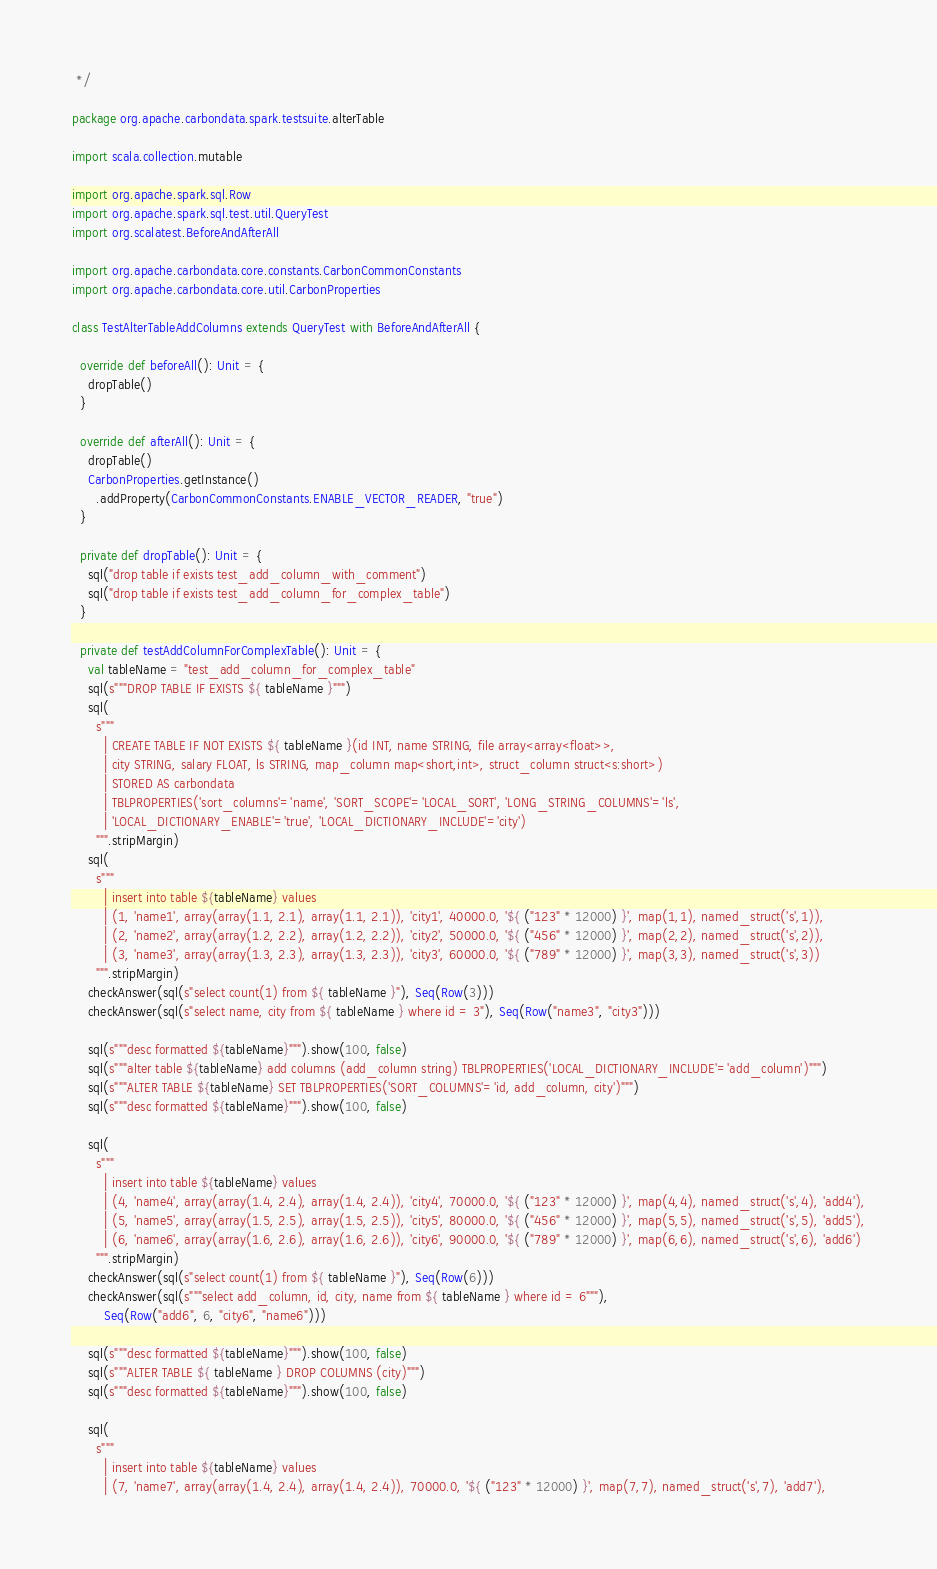<code> <loc_0><loc_0><loc_500><loc_500><_Scala_> */

package org.apache.carbondata.spark.testsuite.alterTable

import scala.collection.mutable

import org.apache.spark.sql.Row
import org.apache.spark.sql.test.util.QueryTest
import org.scalatest.BeforeAndAfterAll

import org.apache.carbondata.core.constants.CarbonCommonConstants
import org.apache.carbondata.core.util.CarbonProperties

class TestAlterTableAddColumns extends QueryTest with BeforeAndAfterAll {

  override def beforeAll(): Unit = {
    dropTable()
  }

  override def afterAll(): Unit = {
    dropTable()
    CarbonProperties.getInstance()
      .addProperty(CarbonCommonConstants.ENABLE_VECTOR_READER, "true")
  }

  private def dropTable(): Unit = {
    sql("drop table if exists test_add_column_with_comment")
    sql("drop table if exists test_add_column_for_complex_table")
  }

  private def testAddColumnForComplexTable(): Unit = {
    val tableName = "test_add_column_for_complex_table"
    sql(s"""DROP TABLE IF EXISTS ${ tableName }""")
    sql(
      s"""
        | CREATE TABLE IF NOT EXISTS ${ tableName }(id INT, name STRING, file array<array<float>>,
        | city STRING, salary FLOAT, ls STRING, map_column map<short,int>, struct_column struct<s:short>)
        | STORED AS carbondata
        | TBLPROPERTIES('sort_columns'='name', 'SORT_SCOPE'='LOCAL_SORT', 'LONG_STRING_COLUMNS'='ls',
        | 'LOCAL_DICTIONARY_ENABLE'='true', 'LOCAL_DICTIONARY_INCLUDE'='city')
      """.stripMargin)
    sql(
      s"""
        | insert into table ${tableName} values
        | (1, 'name1', array(array(1.1, 2.1), array(1.1, 2.1)), 'city1', 40000.0, '${ ("123" * 12000) }', map(1,1), named_struct('s',1)),
        | (2, 'name2', array(array(1.2, 2.2), array(1.2, 2.2)), 'city2', 50000.0, '${ ("456" * 12000) }', map(2,2), named_struct('s',2)),
        | (3, 'name3', array(array(1.3, 2.3), array(1.3, 2.3)), 'city3', 60000.0, '${ ("789" * 12000) }', map(3,3), named_struct('s',3))
      """.stripMargin)
    checkAnswer(sql(s"select count(1) from ${ tableName }"), Seq(Row(3)))
    checkAnswer(sql(s"select name, city from ${ tableName } where id = 3"), Seq(Row("name3", "city3")))

    sql(s"""desc formatted ${tableName}""").show(100, false)
    sql(s"""alter table ${tableName} add columns (add_column string) TBLPROPERTIES('LOCAL_DICTIONARY_INCLUDE'='add_column')""")
    sql(s"""ALTER TABLE ${tableName} SET TBLPROPERTIES('SORT_COLUMNS'='id, add_column, city')""")
    sql(s"""desc formatted ${tableName}""").show(100, false)

    sql(
      s"""
        | insert into table ${tableName} values
        | (4, 'name4', array(array(1.4, 2.4), array(1.4, 2.4)), 'city4', 70000.0, '${ ("123" * 12000) }', map(4,4), named_struct('s',4), 'add4'),
        | (5, 'name5', array(array(1.5, 2.5), array(1.5, 2.5)), 'city5', 80000.0, '${ ("456" * 12000) }', map(5,5), named_struct('s',5), 'add5'),
        | (6, 'name6', array(array(1.6, 2.6), array(1.6, 2.6)), 'city6', 90000.0, '${ ("789" * 12000) }', map(6,6), named_struct('s',6), 'add6')
      """.stripMargin)
    checkAnswer(sql(s"select count(1) from ${ tableName }"), Seq(Row(6)))
    checkAnswer(sql(s"""select add_column, id, city, name from ${ tableName } where id = 6"""),
        Seq(Row("add6", 6, "city6", "name6")))

    sql(s"""desc formatted ${tableName}""").show(100, false)
    sql(s"""ALTER TABLE ${ tableName } DROP COLUMNS (city)""")
    sql(s"""desc formatted ${tableName}""").show(100, false)

    sql(
      s"""
        | insert into table ${tableName} values
        | (7, 'name7', array(array(1.4, 2.4), array(1.4, 2.4)), 70000.0, '${ ("123" * 12000) }', map(7,7), named_struct('s',7), 'add7'),</code> 